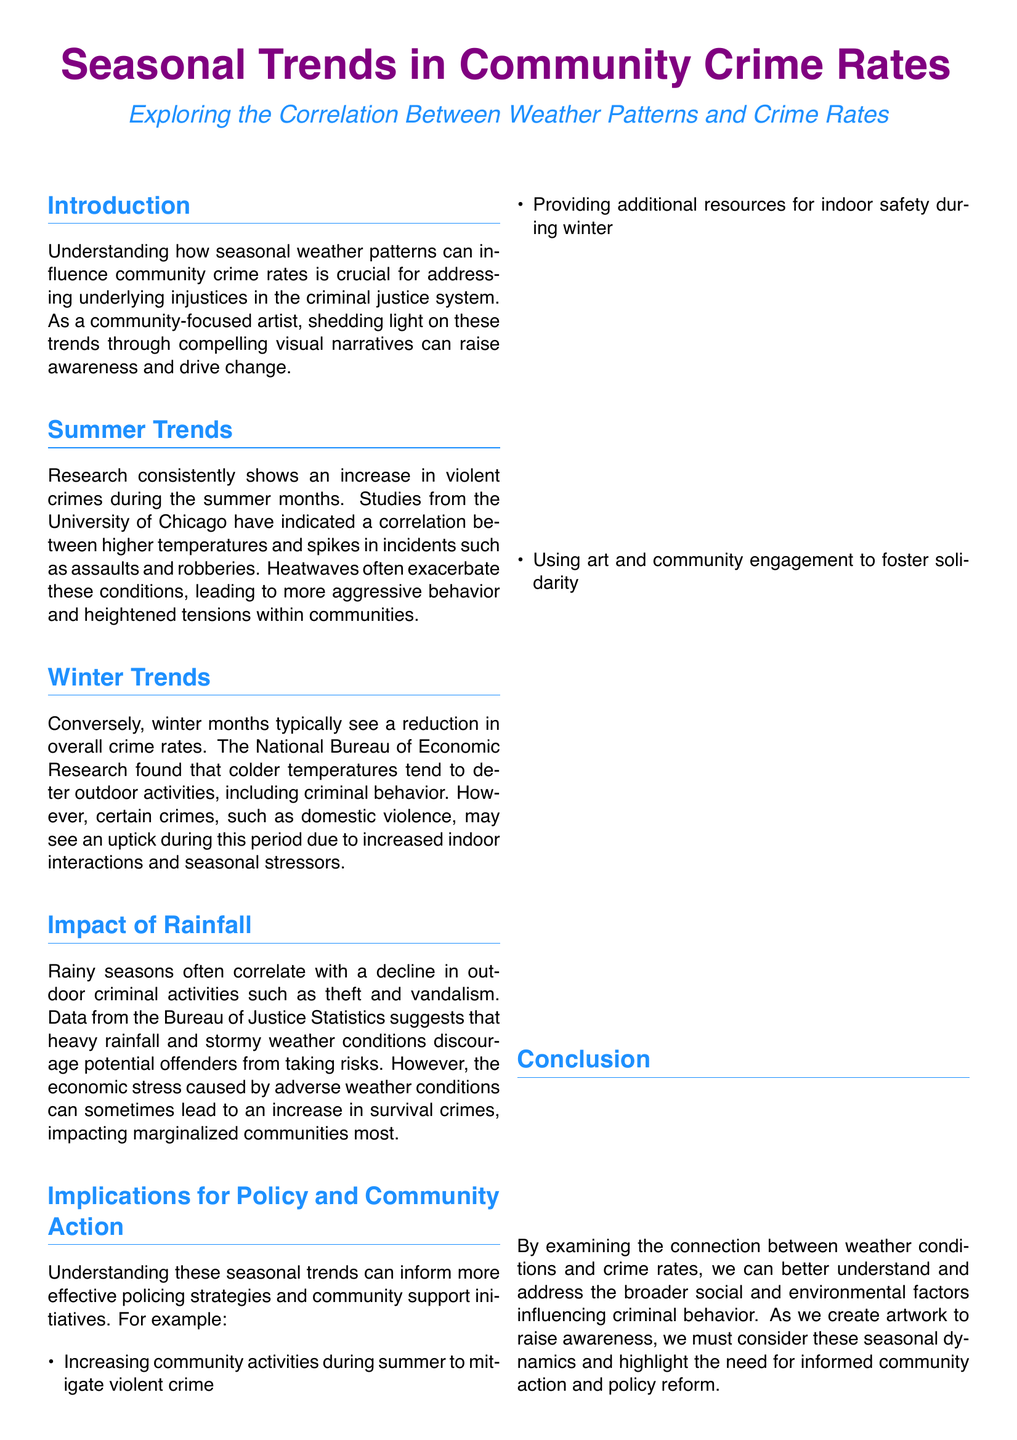What is the primary focus of the report? The report focuses on examining the correlation between seasonal weather patterns and community crime rates.
Answer: Correlation between weather patterns and community crime rates Which season typically sees an increase in violent crimes? The report states that summer months usually see a rise in violent crimes, as indicated by research.
Answer: Summer What happens to crime rates during winter according to the report? The document mentions that winter months generally see a reduction in overall crime rates.
Answer: Reduction in overall crime rates What specific crime may increase during winter months? It is noted that domestic violence may have an uptick during winter due to indoor interactions.
Answer: Domestic violence How do rainy seasons affect outdoor criminal activities? The report states that rainy seasons often correlate with a decline in outdoor criminal activities.
Answer: Decline in outdoor criminal activities What can be a consequence of adverse weather conditions on marginalized communities? The document notes that economic stress from adverse weather can lead to more survival crimes impacting these communities.
Answer: Increase in survival crimes What is one suggested action to mitigate violent crime in summer? The report suggests increasing community activities during summer to mitigate violent crime.
Answer: Increasing community activities Who created the report? The document indicates that it was created by a sibling artist advocating for justice.
Answer: A sibling artist advocating for justice What does the call to action encourage? The call to action encourages collective creativity to advocate for a fair criminal justice system.
Answer: Advocate for a fair criminal justice system 